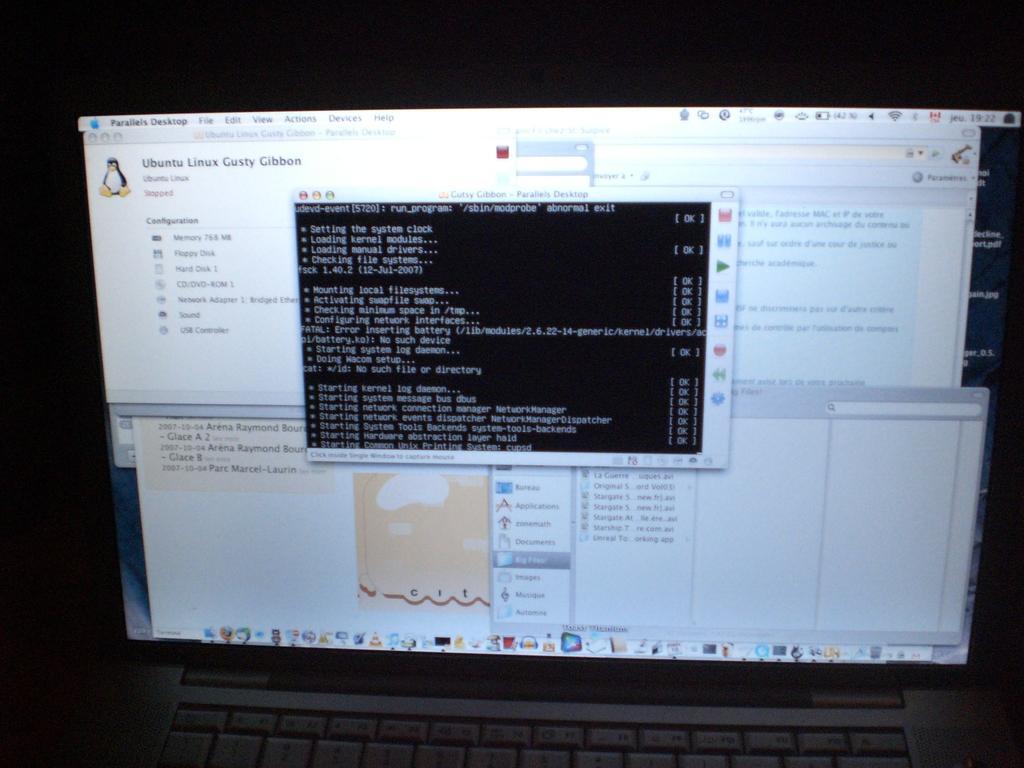In one or two sentences, can you explain what this image depicts? In this picture we can observe a screen of a laptop. We can observe keys here. The background is completely dark. 